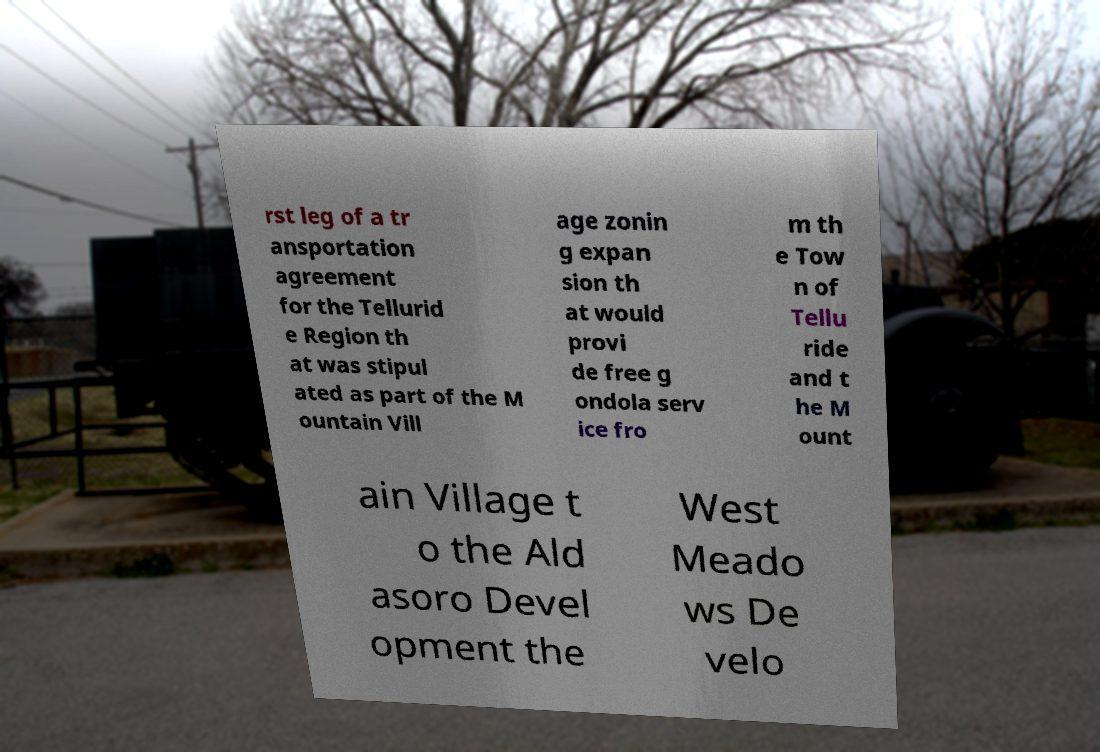I need the written content from this picture converted into text. Can you do that? rst leg of a tr ansportation agreement for the Tellurid e Region th at was stipul ated as part of the M ountain Vill age zonin g expan sion th at would provi de free g ondola serv ice fro m th e Tow n of Tellu ride and t he M ount ain Village t o the Ald asoro Devel opment the West Meado ws De velo 